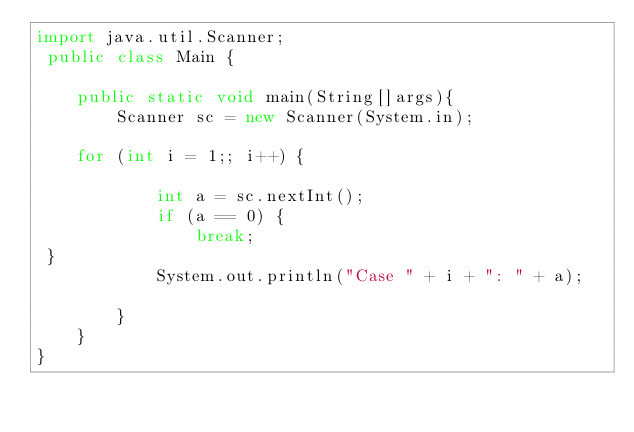Convert code to text. <code><loc_0><loc_0><loc_500><loc_500><_Java_>import java.util.Scanner;
 public class Main {

    public static void main(String[]args){
        Scanner sc = new Scanner(System.in);

    for (int i = 1;; i++) {
 
            int a = sc.nextInt();
            if (a == 0) {
                break;
 }
            System.out.println("Case " + i + ": " + a);
 
        }
    }
}</code> 